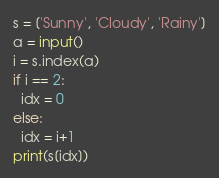Convert code to text. <code><loc_0><loc_0><loc_500><loc_500><_Python_>s = ['Sunny', 'Cloudy', 'Rainy']
a = input()
i = s.index(a)
if i == 2:
  idx = 0
else:
  idx = i+1
print(s[idx])</code> 